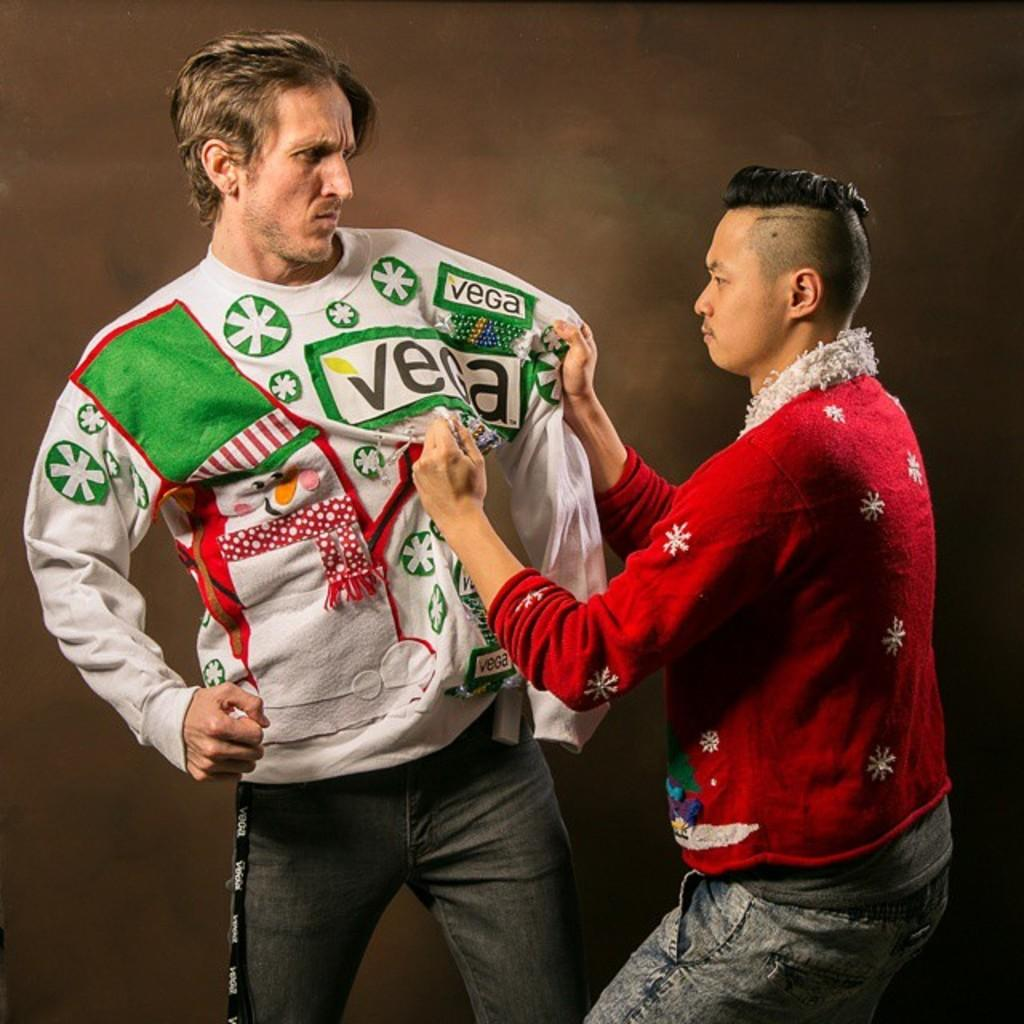Provide a one-sentence caption for the provided image. vega shirt being pulled by another person both with angry faces with one about to punch the other. 